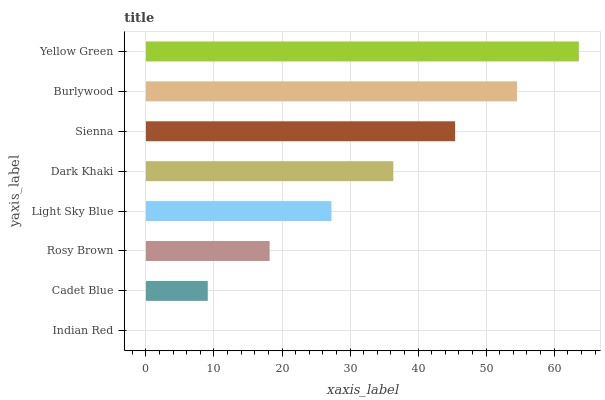Is Indian Red the minimum?
Answer yes or no. Yes. Is Yellow Green the maximum?
Answer yes or no. Yes. Is Cadet Blue the minimum?
Answer yes or no. No. Is Cadet Blue the maximum?
Answer yes or no. No. Is Cadet Blue greater than Indian Red?
Answer yes or no. Yes. Is Indian Red less than Cadet Blue?
Answer yes or no. Yes. Is Indian Red greater than Cadet Blue?
Answer yes or no. No. Is Cadet Blue less than Indian Red?
Answer yes or no. No. Is Dark Khaki the high median?
Answer yes or no. Yes. Is Light Sky Blue the low median?
Answer yes or no. Yes. Is Yellow Green the high median?
Answer yes or no. No. Is Cadet Blue the low median?
Answer yes or no. No. 